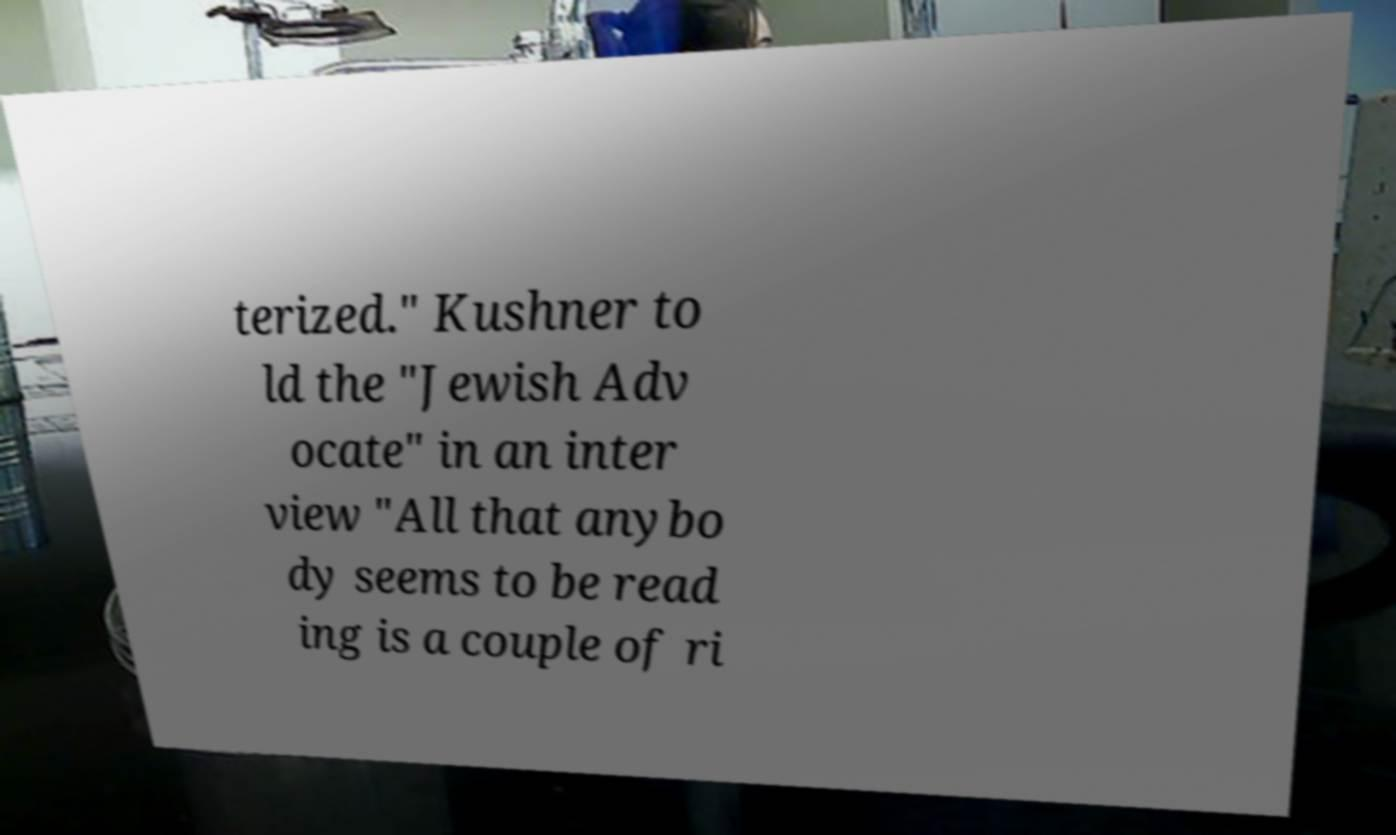There's text embedded in this image that I need extracted. Can you transcribe it verbatim? terized." Kushner to ld the "Jewish Adv ocate" in an inter view "All that anybo dy seems to be read ing is a couple of ri 